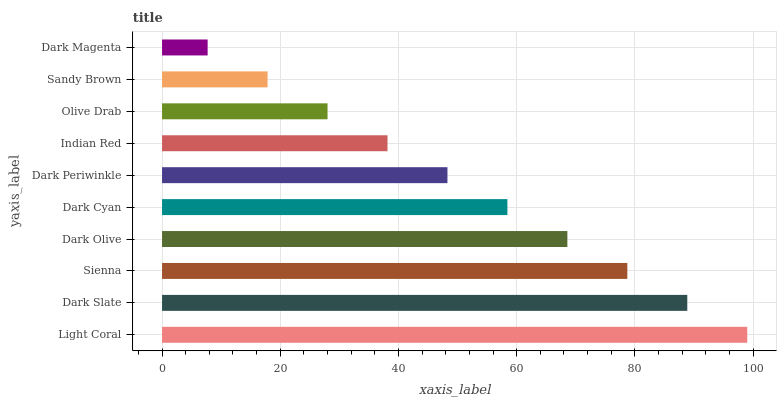Is Dark Magenta the minimum?
Answer yes or no. Yes. Is Light Coral the maximum?
Answer yes or no. Yes. Is Dark Slate the minimum?
Answer yes or no. No. Is Dark Slate the maximum?
Answer yes or no. No. Is Light Coral greater than Dark Slate?
Answer yes or no. Yes. Is Dark Slate less than Light Coral?
Answer yes or no. Yes. Is Dark Slate greater than Light Coral?
Answer yes or no. No. Is Light Coral less than Dark Slate?
Answer yes or no. No. Is Dark Cyan the high median?
Answer yes or no. Yes. Is Dark Periwinkle the low median?
Answer yes or no. Yes. Is Sandy Brown the high median?
Answer yes or no. No. Is Olive Drab the low median?
Answer yes or no. No. 